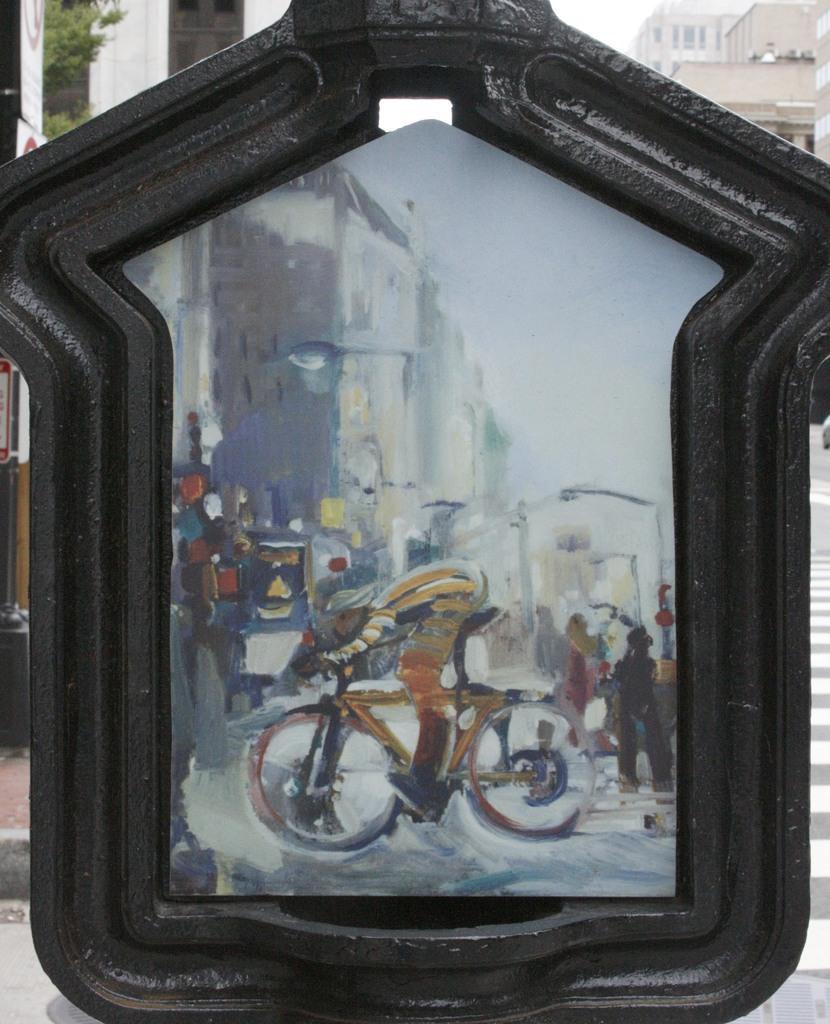Please provide a concise description of this image. In this picture I can see painting on the board, and in the background there are buildings and the sky. 